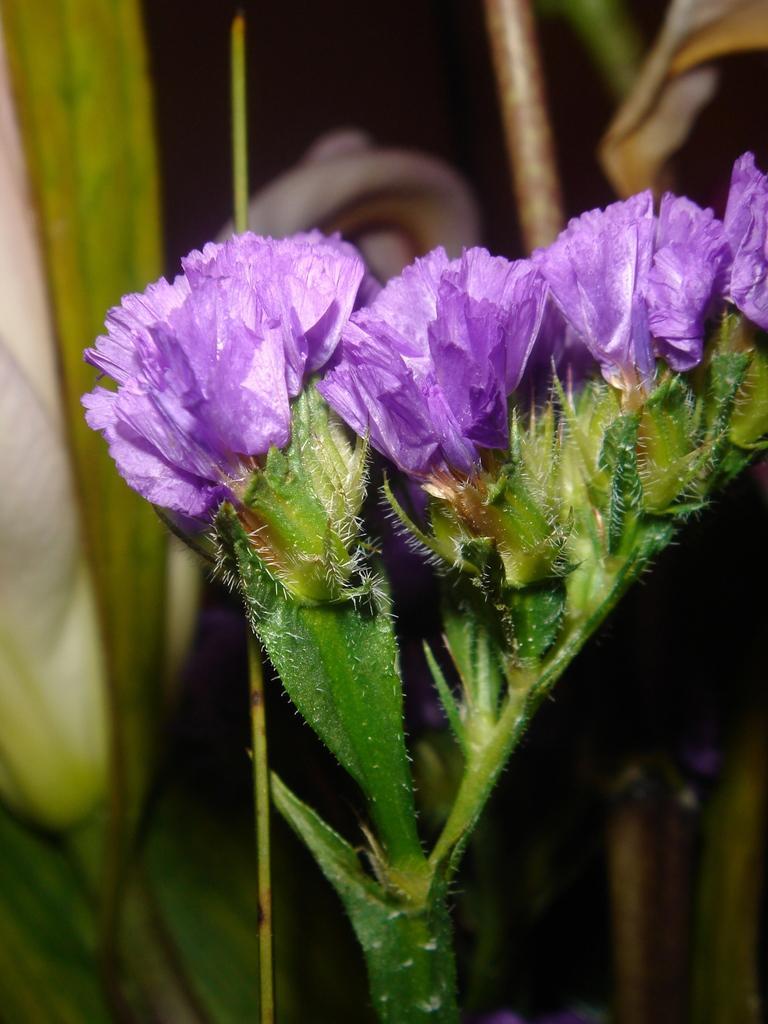Please provide a concise description of this image. In this picture we can see flowers with plants and in the background we can see it is dark. 